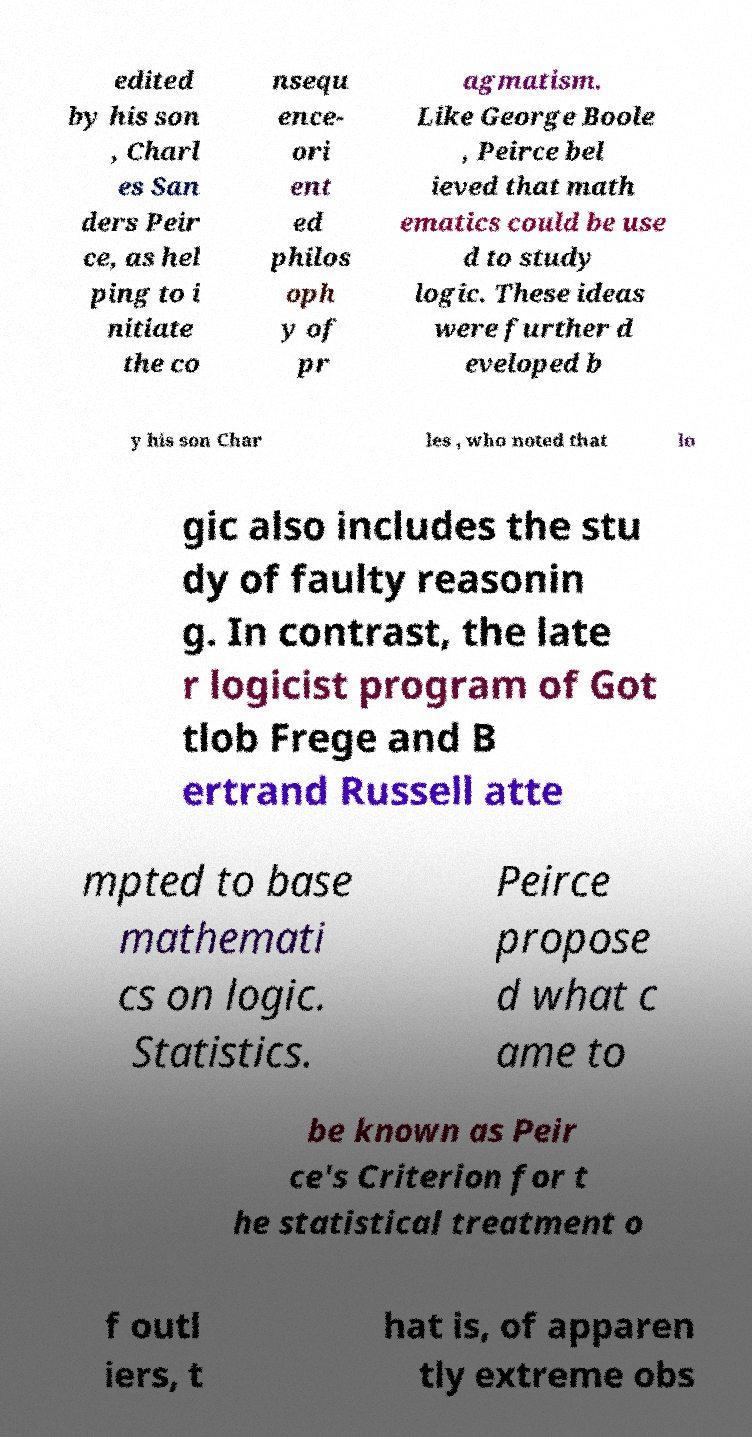Please identify and transcribe the text found in this image. edited by his son , Charl es San ders Peir ce, as hel ping to i nitiate the co nsequ ence- ori ent ed philos oph y of pr agmatism. Like George Boole , Peirce bel ieved that math ematics could be use d to study logic. These ideas were further d eveloped b y his son Char les , who noted that lo gic also includes the stu dy of faulty reasonin g. In contrast, the late r logicist program of Got tlob Frege and B ertrand Russell atte mpted to base mathemati cs on logic. Statistics. Peirce propose d what c ame to be known as Peir ce's Criterion for t he statistical treatment o f outl iers, t hat is, of apparen tly extreme obs 